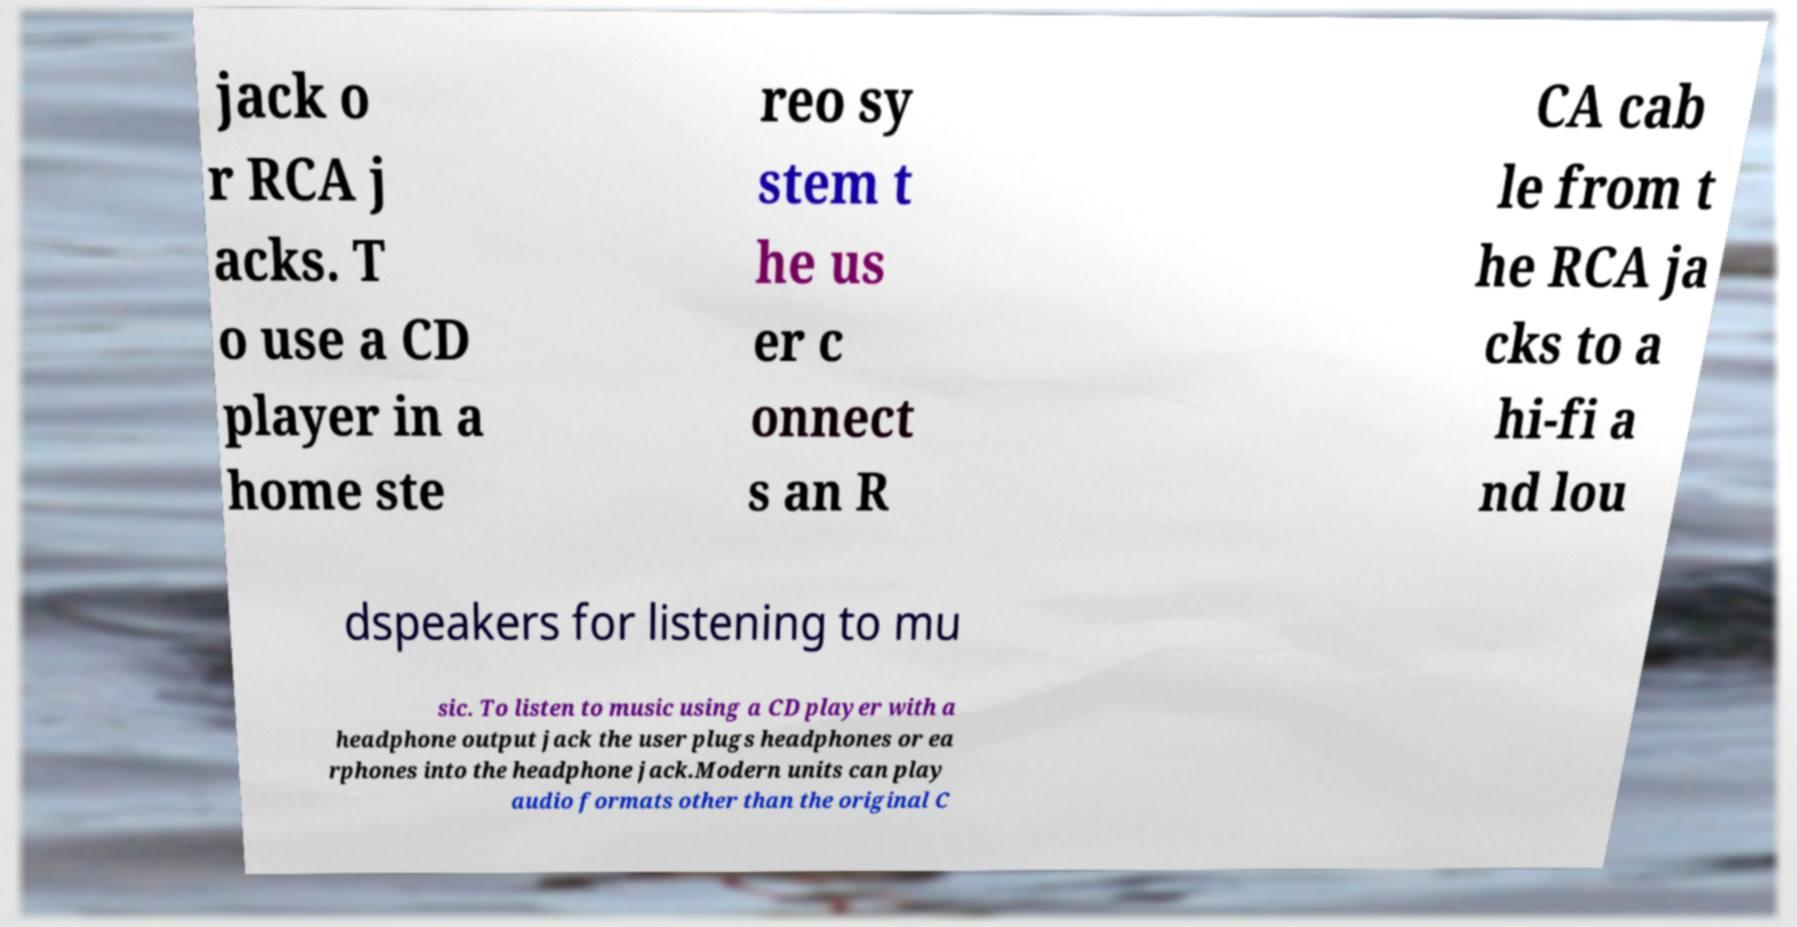For documentation purposes, I need the text within this image transcribed. Could you provide that? jack o r RCA j acks. T o use a CD player in a home ste reo sy stem t he us er c onnect s an R CA cab le from t he RCA ja cks to a hi-fi a nd lou dspeakers for listening to mu sic. To listen to music using a CD player with a headphone output jack the user plugs headphones or ea rphones into the headphone jack.Modern units can play audio formats other than the original C 